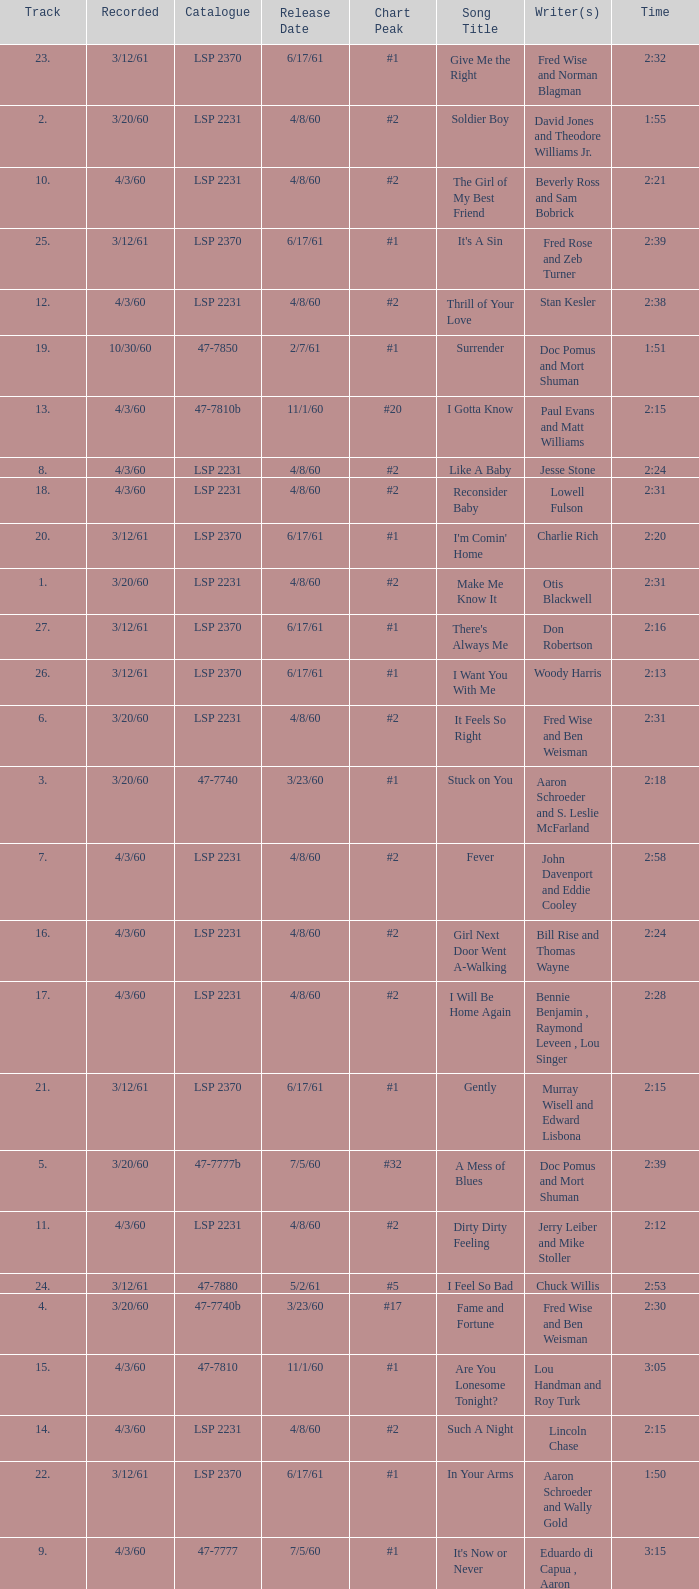On songs with track numbers smaller than number 17 and catalogues of LSP 2231, who are the writer(s)? Otis Blackwell, David Jones and Theodore Williams Jr., Fred Wise and Ben Weisman, John Davenport and Eddie Cooley, Jesse Stone, Beverly Ross and Sam Bobrick, Jerry Leiber and Mike Stoller, Stan Kesler, Lincoln Chase, Bill Rise and Thomas Wayne. 